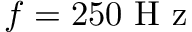<formula> <loc_0><loc_0><loc_500><loc_500>f = 2 5 0 H z</formula> 